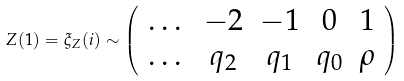Convert formula to latex. <formula><loc_0><loc_0><loc_500><loc_500>Z ( 1 ) = \xi _ { Z } ( i ) \sim \left ( \begin{array} { c c c c c } \dots & - 2 & - 1 & 0 & 1 \\ \dots & q _ { 2 } & q _ { 1 } & q _ { 0 } & \rho \\ \end{array} \right )</formula> 